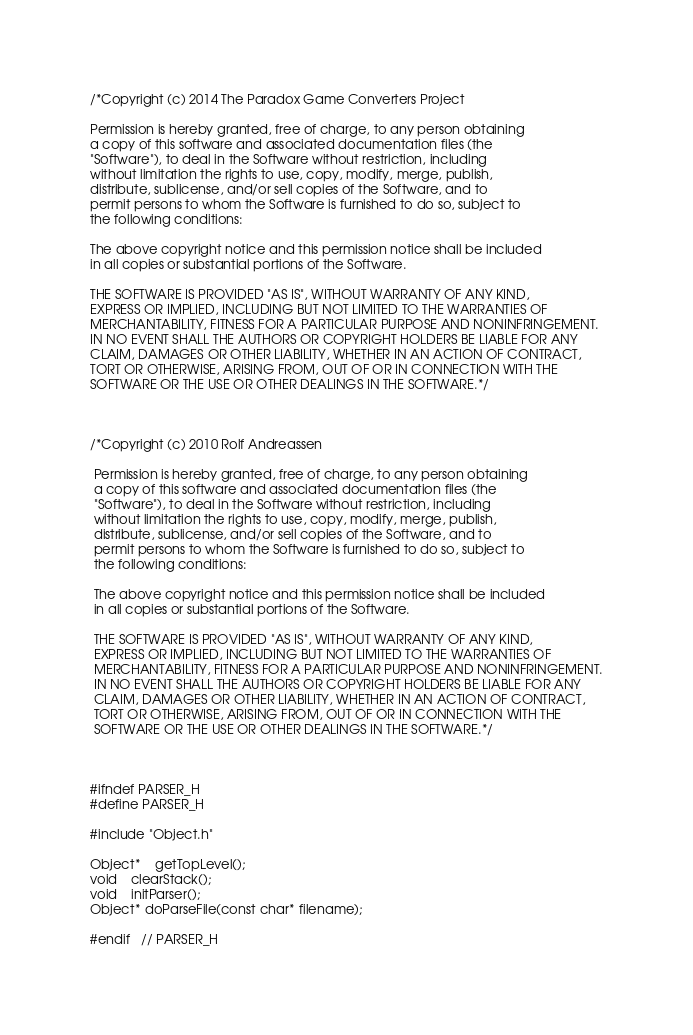Convert code to text. <code><loc_0><loc_0><loc_500><loc_500><_C_>/*Copyright (c) 2014 The Paradox Game Converters Project

Permission is hereby granted, free of charge, to any person obtaining
a copy of this software and associated documentation files (the
"Software"), to deal in the Software without restriction, including
without limitation the rights to use, copy, modify, merge, publish,
distribute, sublicense, and/or sell copies of the Software, and to
permit persons to whom the Software is furnished to do so, subject to
the following conditions:

The above copyright notice and this permission notice shall be included
in all copies or substantial portions of the Software.

THE SOFTWARE IS PROVIDED "AS IS", WITHOUT WARRANTY OF ANY KIND,
EXPRESS OR IMPLIED, INCLUDING BUT NOT LIMITED TO THE WARRANTIES OF
MERCHANTABILITY, FITNESS FOR A PARTICULAR PURPOSE AND NONINFRINGEMENT.
IN NO EVENT SHALL THE AUTHORS OR COPYRIGHT HOLDERS BE LIABLE FOR ANY
CLAIM, DAMAGES OR OTHER LIABILITY, WHETHER IN AN ACTION OF CONTRACT,
TORT OR OTHERWISE, ARISING FROM, OUT OF OR IN CONNECTION WITH THE
SOFTWARE OR THE USE OR OTHER DEALINGS IN THE SOFTWARE.*/



/*Copyright (c) 2010 Rolf Andreassen
 
 Permission is hereby granted, free of charge, to any person obtaining
 a copy of this software and associated documentation files (the
 "Software"), to deal in the Software without restriction, including
 without limitation the rights to use, copy, modify, merge, publish,
 distribute, sublicense, and/or sell copies of the Software, and to
 permit persons to whom the Software is furnished to do so, subject to
 the following conditions:
 
 The above copyright notice and this permission notice shall be included
 in all copies or substantial portions of the Software.
 
 THE SOFTWARE IS PROVIDED "AS IS", WITHOUT WARRANTY OF ANY KIND,
 EXPRESS OR IMPLIED, INCLUDING BUT NOT LIMITED TO THE WARRANTIES OF
 MERCHANTABILITY, FITNESS FOR A PARTICULAR PURPOSE AND NONINFRINGEMENT.
 IN NO EVENT SHALL THE AUTHORS OR COPYRIGHT HOLDERS BE LIABLE FOR ANY
 CLAIM, DAMAGES OR OTHER LIABILITY, WHETHER IN AN ACTION OF CONTRACT,
 TORT OR OTHERWISE, ARISING FROM, OUT OF OR IN CONNECTION WITH THE
 SOFTWARE OR THE USE OR OTHER DEALINGS IN THE SOFTWARE.*/



#ifndef PARSER_H
#define PARSER_H

#include "Object.h"

Object*	getTopLevel();
void	clearStack(); 
void	initParser();
Object* doParseFile(const char* filename);

#endif	// PARSER_H
</code> 